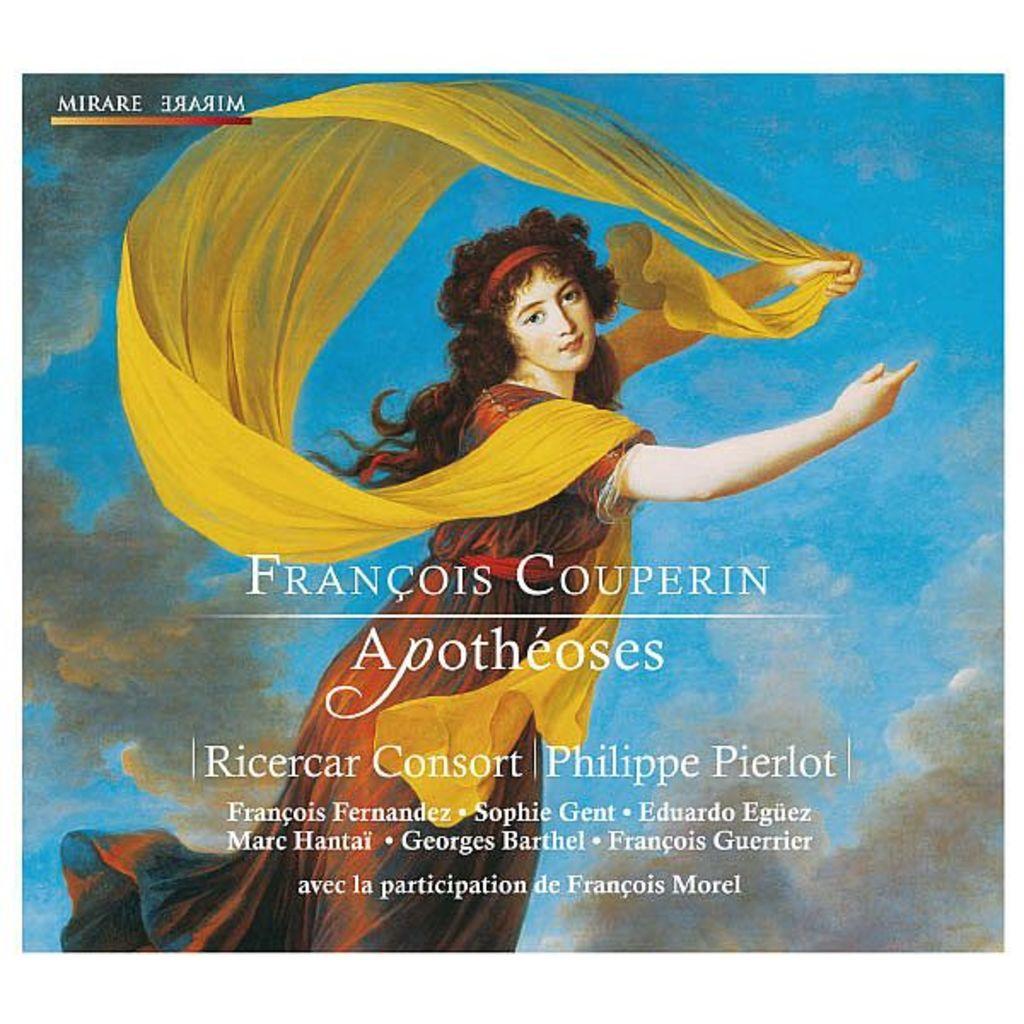What word is in the top left corner?
Provide a short and direct response. Mirare. Who is the author of this text?
Provide a succinct answer. Francois couperin. 